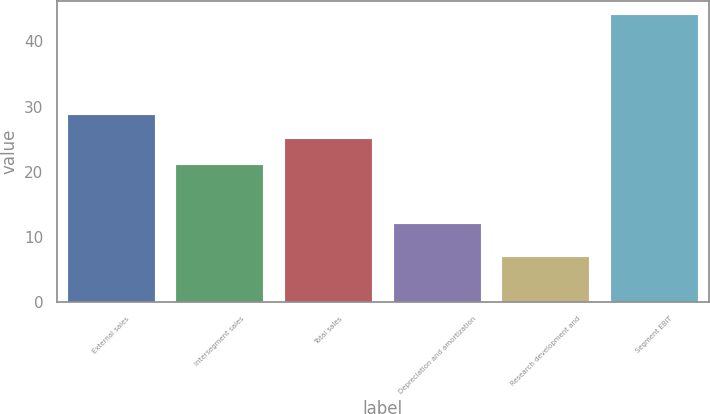Convert chart. <chart><loc_0><loc_0><loc_500><loc_500><bar_chart><fcel>External sales<fcel>Intersegment sales<fcel>Total sales<fcel>Depreciation and amortization<fcel>Research development and<fcel>Segment EBIT<nl><fcel>28.7<fcel>21<fcel>25<fcel>12<fcel>7<fcel>44<nl></chart> 